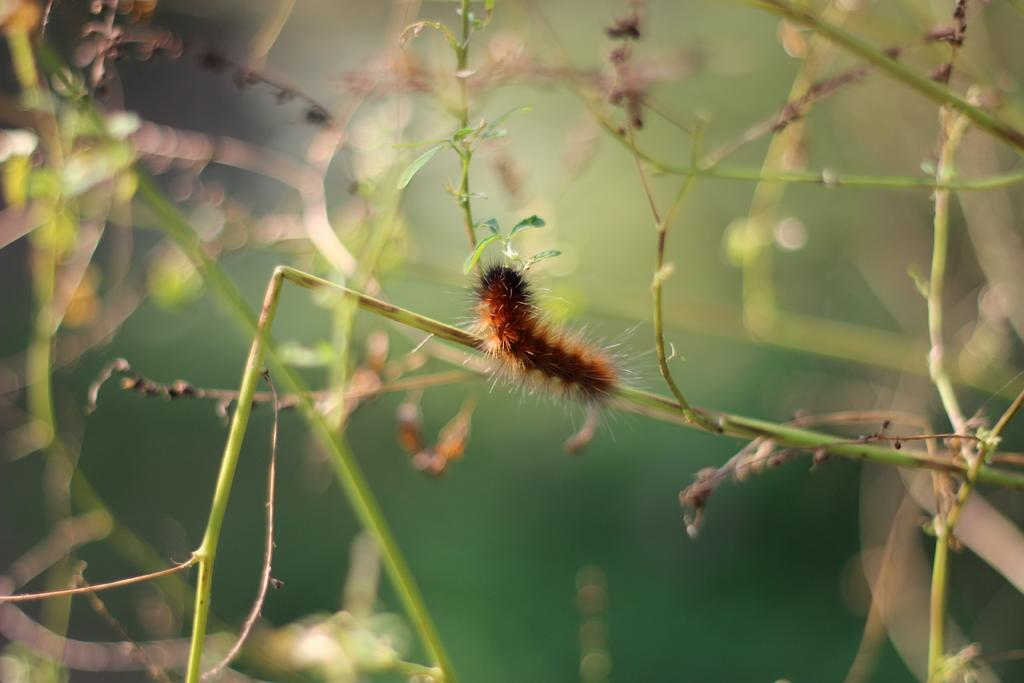What is the main subject of the image? There is an insect on a plant stem in the image. Where is the insect located in relation to the image? The insect is in the center of the image. What can be observed about the background of the image? The background of the image is blurred. How many children are visible playing with the vessel in the image? There are no children or vessels present in the image. What type of cakes are being served on the table in the image? There is no table or cakes present in the image. 